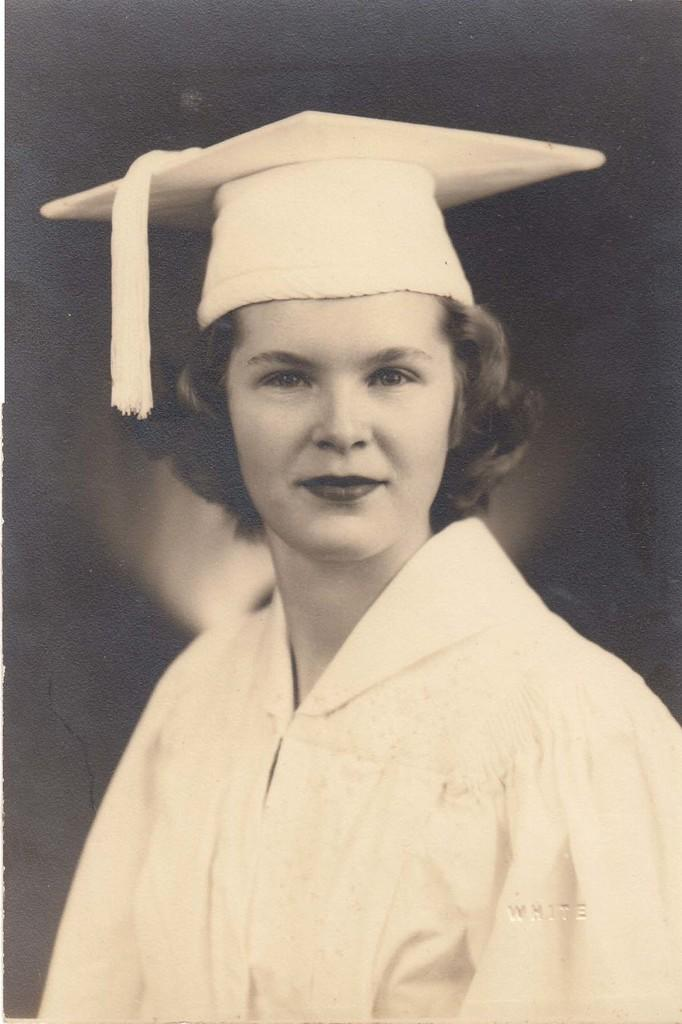Who is the main subject in the foreground of the image? There is a woman in the foreground of the image. What is the woman wearing on her head? The woman is wearing a hat. What is the color of the background in the image? The background of the image is black. Can you describe the lighting in the image? There is some light visible in the image. What is the writer's dad doing in the image? There is no writer or dad present in the image; it features a woman wearing a hat with a black background and some visible light. 